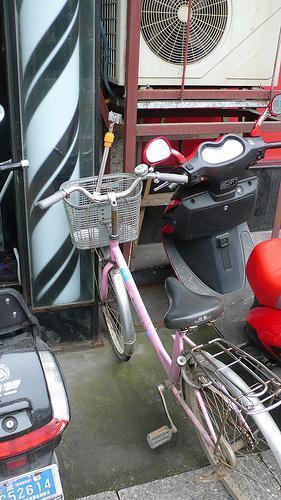How many bicycles are pictured?
Give a very brief answer. 1. 